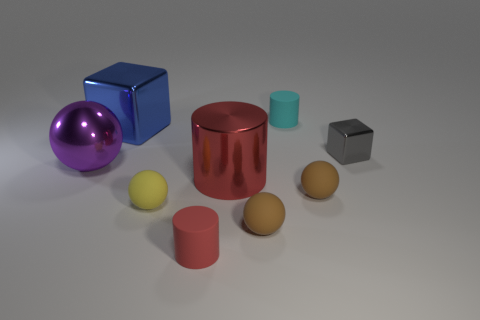Subtract all purple spheres. How many spheres are left? 3 Subtract all purple balls. How many balls are left? 3 Subtract 2 balls. How many balls are left? 2 Subtract all blocks. How many objects are left? 7 Add 1 large spheres. How many objects exist? 10 Subtract all cyan balls. Subtract all red cubes. How many balls are left? 4 Subtract 0 gray spheres. How many objects are left? 9 Subtract all large cyan cubes. Subtract all cyan rubber things. How many objects are left? 8 Add 1 yellow things. How many yellow things are left? 2 Add 8 gray balls. How many gray balls exist? 8 